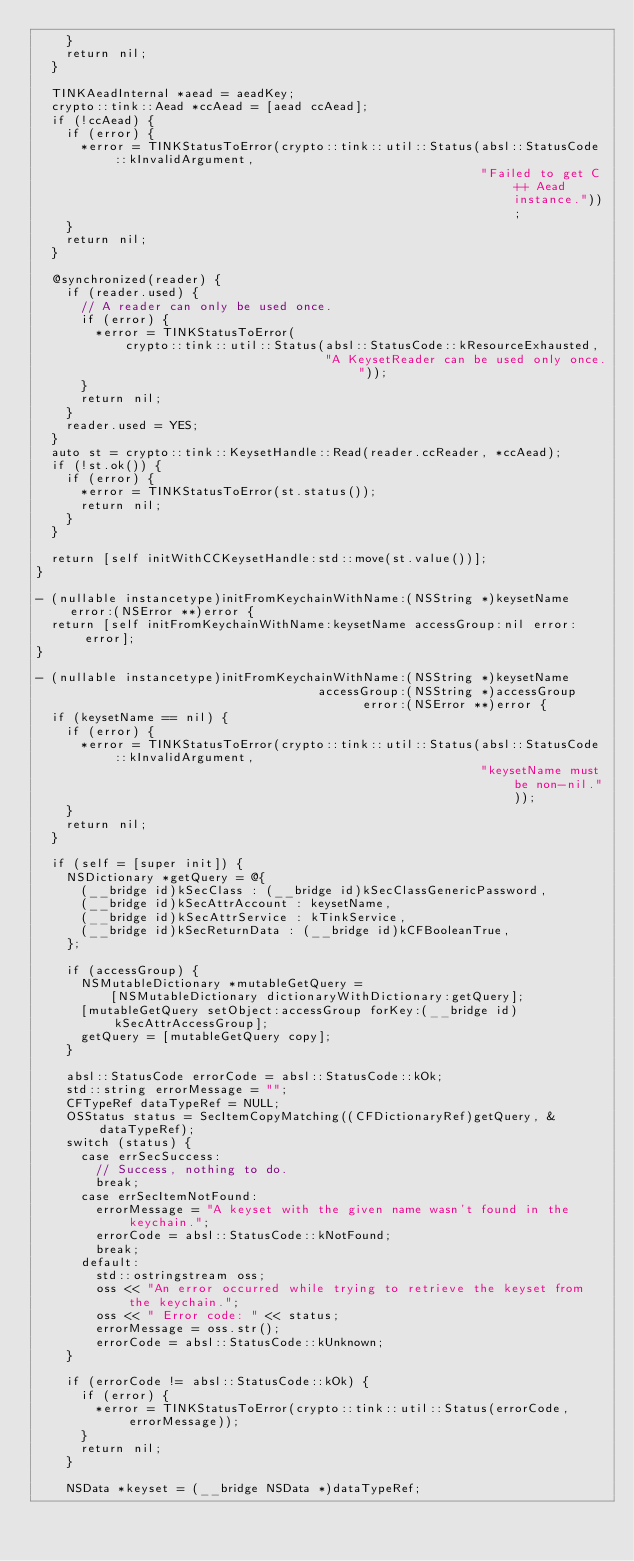Convert code to text. <code><loc_0><loc_0><loc_500><loc_500><_ObjectiveC_>    }
    return nil;
  }

  TINKAeadInternal *aead = aeadKey;
  crypto::tink::Aead *ccAead = [aead ccAead];
  if (!ccAead) {
    if (error) {
      *error = TINKStatusToError(crypto::tink::util::Status(absl::StatusCode::kInvalidArgument,
                                                            "Failed to get C++ Aead instance."));
    }
    return nil;
  }

  @synchronized(reader) {
    if (reader.used) {
      // A reader can only be used once.
      if (error) {
        *error = TINKStatusToError(
            crypto::tink::util::Status(absl::StatusCode::kResourceExhausted,
                                       "A KeysetReader can be used only once."));
      }
      return nil;
    }
    reader.used = YES;
  }
  auto st = crypto::tink::KeysetHandle::Read(reader.ccReader, *ccAead);
  if (!st.ok()) {
    if (error) {
      *error = TINKStatusToError(st.status());
      return nil;
    }
  }

  return [self initWithCCKeysetHandle:std::move(st.value())];
}

- (nullable instancetype)initFromKeychainWithName:(NSString *)keysetName error:(NSError **)error {
  return [self initFromKeychainWithName:keysetName accessGroup:nil error:error];
}

- (nullable instancetype)initFromKeychainWithName:(NSString *)keysetName
                                      accessGroup:(NSString *)accessGroup
                                            error:(NSError **)error {
  if (keysetName == nil) {
    if (error) {
      *error = TINKStatusToError(crypto::tink::util::Status(absl::StatusCode::kInvalidArgument,
                                                            "keysetName must be non-nil."));
    }
    return nil;
  }

  if (self = [super init]) {
    NSDictionary *getQuery = @{
      (__bridge id)kSecClass : (__bridge id)kSecClassGenericPassword,
      (__bridge id)kSecAttrAccount : keysetName,
      (__bridge id)kSecAttrService : kTinkService,
      (__bridge id)kSecReturnData : (__bridge id)kCFBooleanTrue,
    };

    if (accessGroup) {
      NSMutableDictionary *mutableGetQuery =
          [NSMutableDictionary dictionaryWithDictionary:getQuery];
      [mutableGetQuery setObject:accessGroup forKey:(__bridge id)kSecAttrAccessGroup];
      getQuery = [mutableGetQuery copy];
    }

    absl::StatusCode errorCode = absl::StatusCode::kOk;
    std::string errorMessage = "";
    CFTypeRef dataTypeRef = NULL;
    OSStatus status = SecItemCopyMatching((CFDictionaryRef)getQuery, &dataTypeRef);
    switch (status) {
      case errSecSuccess:
        // Success, nothing to do.
        break;
      case errSecItemNotFound:
        errorMessage = "A keyset with the given name wasn't found in the keychain.";
        errorCode = absl::StatusCode::kNotFound;
        break;
      default:
        std::ostringstream oss;
        oss << "An error occurred while trying to retrieve the keyset from the keychain.";
        oss << " Error code: " << status;
        errorMessage = oss.str();
        errorCode = absl::StatusCode::kUnknown;
    }

    if (errorCode != absl::StatusCode::kOk) {
      if (error) {
        *error = TINKStatusToError(crypto::tink::util::Status(errorCode, errorMessage));
      }
      return nil;
    }

    NSData *keyset = (__bridge NSData *)dataTypeRef;</code> 